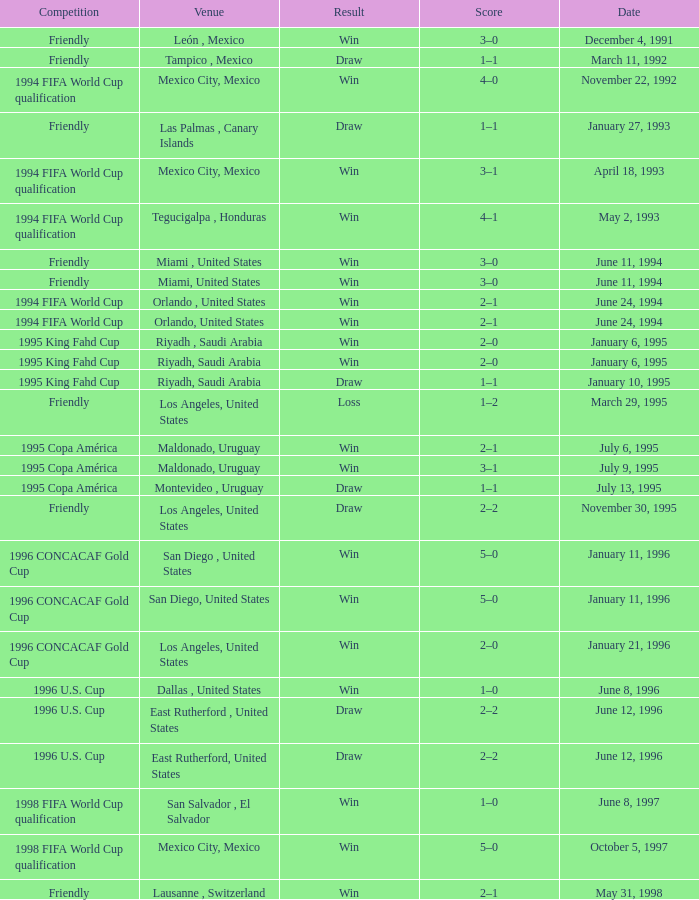What is Competition, when Date is "January 11, 1996", when Venue is "San Diego , United States"? 1996 CONCACAF Gold Cup, 1996 CONCACAF Gold Cup. 